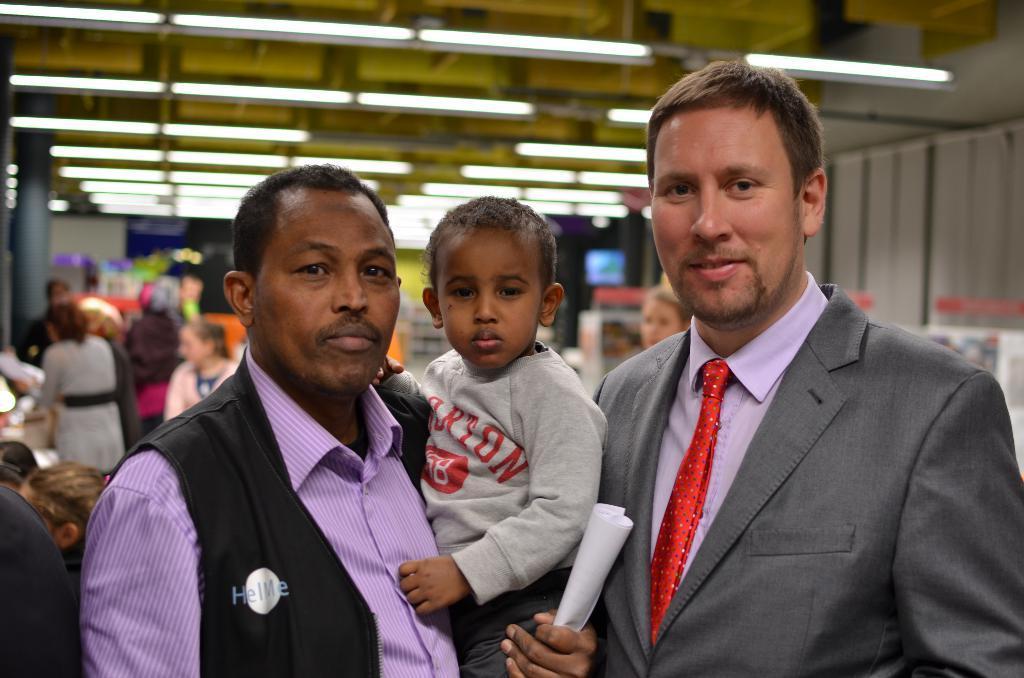How would you summarize this image in a sentence or two? In this picture we can see few persons. In the background we can see lights, wall, pillar, and objects. 